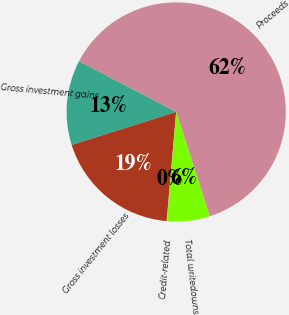Convert chart. <chart><loc_0><loc_0><loc_500><loc_500><pie_chart><fcel>Proceeds<fcel>Gross investment gains<fcel>Gross investment losses<fcel>Credit-related<fcel>Total writedowns<nl><fcel>62.4%<fcel>12.52%<fcel>18.75%<fcel>0.05%<fcel>6.28%<nl></chart> 